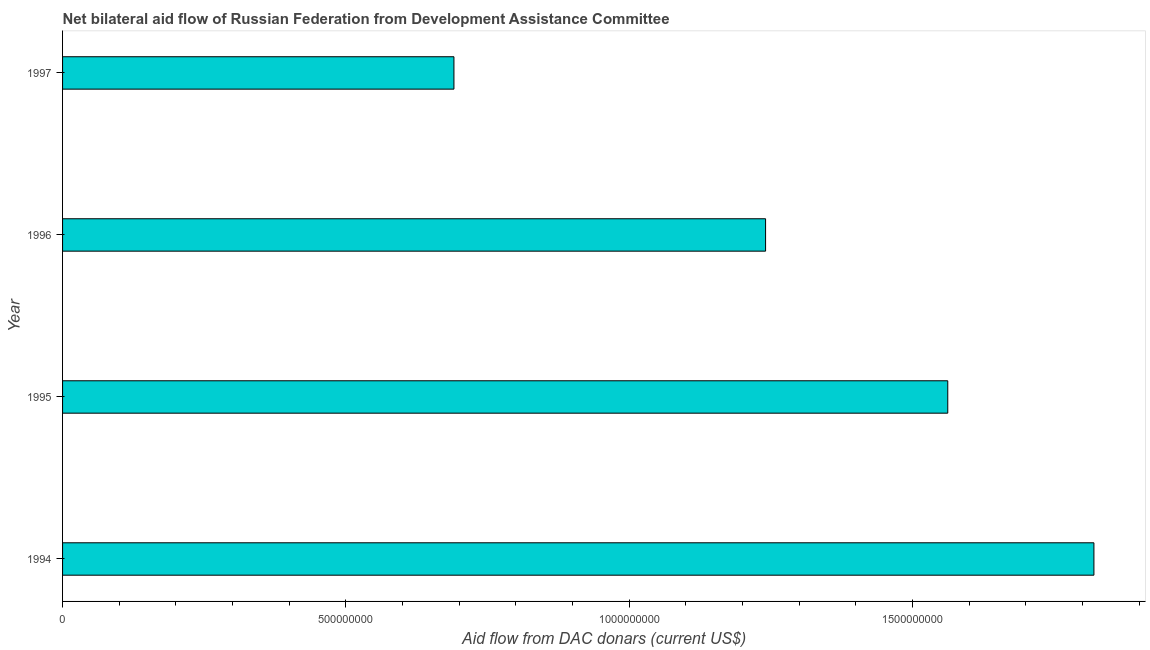Does the graph contain any zero values?
Offer a terse response. No. What is the title of the graph?
Give a very brief answer. Net bilateral aid flow of Russian Federation from Development Assistance Committee. What is the label or title of the X-axis?
Make the answer very short. Aid flow from DAC donars (current US$). What is the label or title of the Y-axis?
Your answer should be compact. Year. What is the net bilateral aid flows from dac donors in 1996?
Make the answer very short. 1.24e+09. Across all years, what is the maximum net bilateral aid flows from dac donors?
Offer a very short reply. 1.82e+09. Across all years, what is the minimum net bilateral aid flows from dac donors?
Provide a short and direct response. 6.91e+08. In which year was the net bilateral aid flows from dac donors maximum?
Your response must be concise. 1994. What is the sum of the net bilateral aid flows from dac donors?
Provide a short and direct response. 5.31e+09. What is the difference between the net bilateral aid flows from dac donors in 1994 and 1995?
Ensure brevity in your answer.  2.58e+08. What is the average net bilateral aid flows from dac donors per year?
Your response must be concise. 1.33e+09. What is the median net bilateral aid flows from dac donors?
Your answer should be very brief. 1.40e+09. In how many years, is the net bilateral aid flows from dac donors greater than 100000000 US$?
Your response must be concise. 4. What is the ratio of the net bilateral aid flows from dac donors in 1996 to that in 1997?
Keep it short and to the point. 1.8. Is the net bilateral aid flows from dac donors in 1994 less than that in 1997?
Ensure brevity in your answer.  No. Is the difference between the net bilateral aid flows from dac donors in 1996 and 1997 greater than the difference between any two years?
Your response must be concise. No. What is the difference between the highest and the second highest net bilateral aid flows from dac donors?
Keep it short and to the point. 2.58e+08. Is the sum of the net bilateral aid flows from dac donors in 1996 and 1997 greater than the maximum net bilateral aid flows from dac donors across all years?
Provide a short and direct response. Yes. What is the difference between the highest and the lowest net bilateral aid flows from dac donors?
Offer a very short reply. 1.13e+09. In how many years, is the net bilateral aid flows from dac donors greater than the average net bilateral aid flows from dac donors taken over all years?
Give a very brief answer. 2. How many bars are there?
Offer a very short reply. 4. Are all the bars in the graph horizontal?
Your answer should be very brief. Yes. How many years are there in the graph?
Offer a terse response. 4. What is the Aid flow from DAC donars (current US$) in 1994?
Give a very brief answer. 1.82e+09. What is the Aid flow from DAC donars (current US$) in 1995?
Give a very brief answer. 1.56e+09. What is the Aid flow from DAC donars (current US$) in 1996?
Give a very brief answer. 1.24e+09. What is the Aid flow from DAC donars (current US$) of 1997?
Give a very brief answer. 6.91e+08. What is the difference between the Aid flow from DAC donars (current US$) in 1994 and 1995?
Provide a succinct answer. 2.58e+08. What is the difference between the Aid flow from DAC donars (current US$) in 1994 and 1996?
Provide a short and direct response. 5.79e+08. What is the difference between the Aid flow from DAC donars (current US$) in 1994 and 1997?
Give a very brief answer. 1.13e+09. What is the difference between the Aid flow from DAC donars (current US$) in 1995 and 1996?
Make the answer very short. 3.22e+08. What is the difference between the Aid flow from DAC donars (current US$) in 1995 and 1997?
Your answer should be very brief. 8.71e+08. What is the difference between the Aid flow from DAC donars (current US$) in 1996 and 1997?
Give a very brief answer. 5.50e+08. What is the ratio of the Aid flow from DAC donars (current US$) in 1994 to that in 1995?
Give a very brief answer. 1.17. What is the ratio of the Aid flow from DAC donars (current US$) in 1994 to that in 1996?
Offer a terse response. 1.47. What is the ratio of the Aid flow from DAC donars (current US$) in 1994 to that in 1997?
Your answer should be compact. 2.63. What is the ratio of the Aid flow from DAC donars (current US$) in 1995 to that in 1996?
Offer a very short reply. 1.26. What is the ratio of the Aid flow from DAC donars (current US$) in 1995 to that in 1997?
Keep it short and to the point. 2.26. What is the ratio of the Aid flow from DAC donars (current US$) in 1996 to that in 1997?
Your answer should be compact. 1.8. 